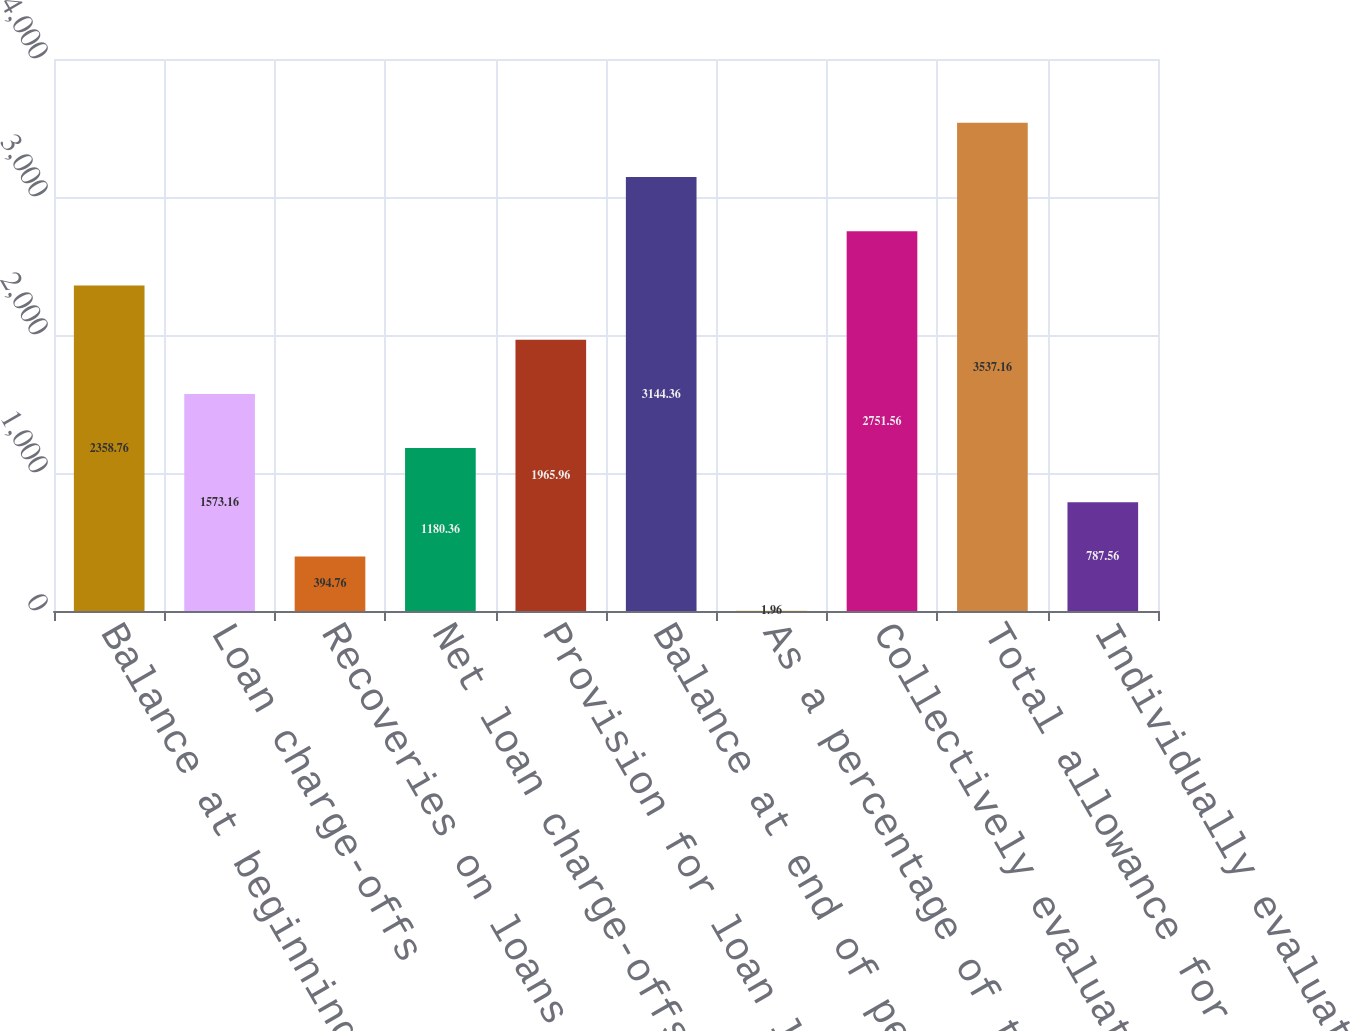Convert chart. <chart><loc_0><loc_0><loc_500><loc_500><bar_chart><fcel>Balance at beginning of period<fcel>Loan charge-offs<fcel>Recoveries on loans previously<fcel>Net loan charge-offs<fcel>Provision for loan losses<fcel>Balance at end of period<fcel>As a percentage of total loans<fcel>Collectively evaluated for<fcel>Total allowance for loan<fcel>Individually evaluated for<nl><fcel>2358.76<fcel>1573.16<fcel>394.76<fcel>1180.36<fcel>1965.96<fcel>3144.36<fcel>1.96<fcel>2751.56<fcel>3537.16<fcel>787.56<nl></chart> 